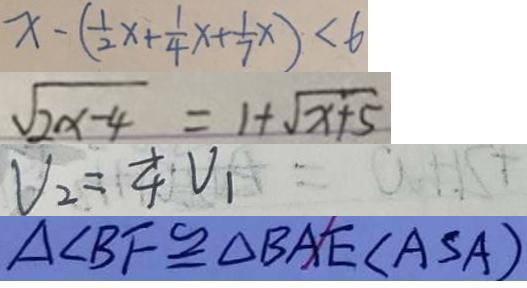<formula> <loc_0><loc_0><loc_500><loc_500>x - ( \frac { 1 } { 2 } x + \frac { 1 } { 4 } x + \frac { 1 } { 7 } x ) < 6 
 \sqrt { 2 x - 4 } = 1 + \sqrt { x + 5 } 
 V _ { 2 } = \frac { 1 } { 4 } V _ { 1 } 
 \Delta B F \cong \Delta B A E ( A S A )</formula> 